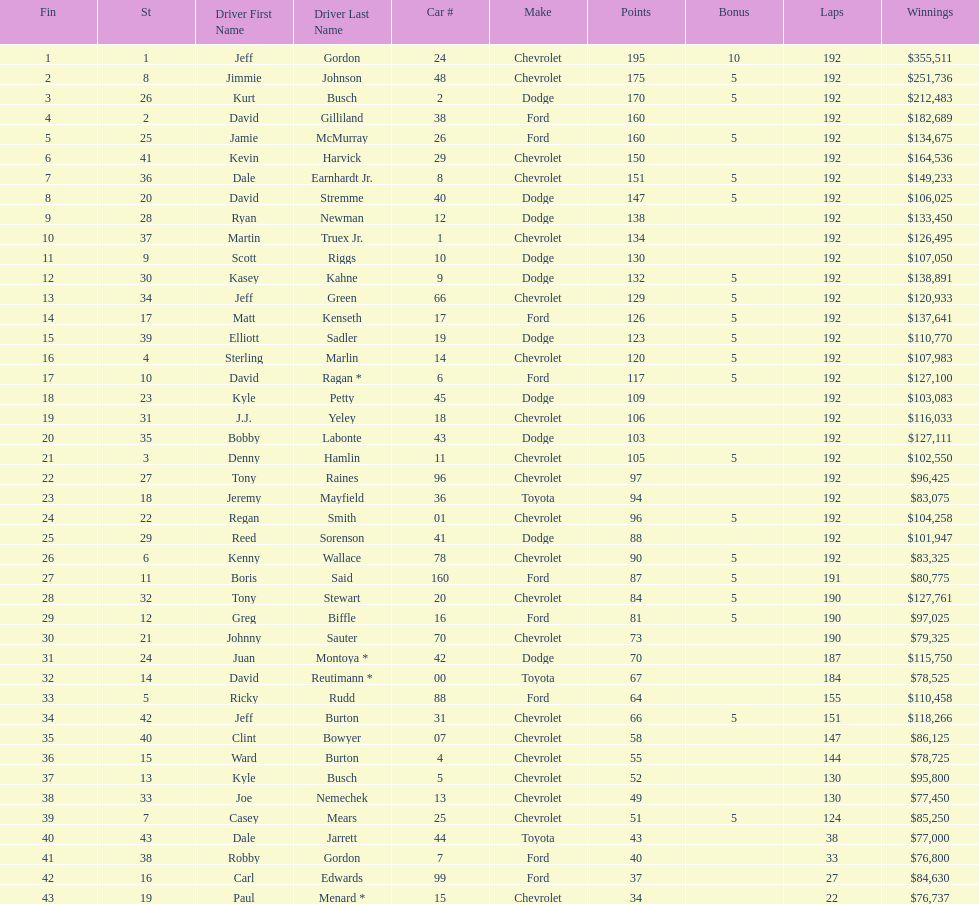Could you parse the entire table? {'header': ['Fin', 'St', 'Driver First Name', 'Driver Last Name', 'Car #', 'Make', 'Points', 'Bonus', 'Laps', 'Winnings'], 'rows': [['1', '1', 'Jeff', 'Gordon', '24', 'Chevrolet', '195', '10', '192', '$355,511'], ['2', '8', 'Jimmie', 'Johnson', '48', 'Chevrolet', '175', '5', '192', '$251,736'], ['3', '26', 'Kurt', 'Busch', '2', 'Dodge', '170', '5', '192', '$212,483'], ['4', '2', 'David', 'Gilliland', '38', 'Ford', '160', '', '192', '$182,689'], ['5', '25', 'Jamie', 'McMurray', '26', 'Ford', '160', '5', '192', '$134,675'], ['6', '41', 'Kevin', 'Harvick', '29', 'Chevrolet', '150', '', '192', '$164,536'], ['7', '36', 'Dale', 'Earnhardt Jr.', '8', 'Chevrolet', '151', '5', '192', '$149,233'], ['8', '20', 'David', 'Stremme', '40', 'Dodge', '147', '5', '192', '$106,025'], ['9', '28', 'Ryan', 'Newman', '12', 'Dodge', '138', '', '192', '$133,450'], ['10', '37', 'Martin', 'Truex Jr.', '1', 'Chevrolet', '134', '', '192', '$126,495'], ['11', '9', 'Scott', 'Riggs', '10', 'Dodge', '130', '', '192', '$107,050'], ['12', '30', 'Kasey', 'Kahne', '9', 'Dodge', '132', '5', '192', '$138,891'], ['13', '34', 'Jeff', 'Green', '66', 'Chevrolet', '129', '5', '192', '$120,933'], ['14', '17', 'Matt', 'Kenseth', '17', 'Ford', '126', '5', '192', '$137,641'], ['15', '39', 'Elliott', 'Sadler', '19', 'Dodge', '123', '5', '192', '$110,770'], ['16', '4', 'Sterling', 'Marlin', '14', 'Chevrolet', '120', '5', '192', '$107,983'], ['17', '10', 'David', 'Ragan *', '6', 'Ford', '117', '5', '192', '$127,100'], ['18', '23', 'Kyle', 'Petty', '45', 'Dodge', '109', '', '192', '$103,083'], ['19', '31', 'J.J.', 'Yeley', '18', 'Chevrolet', '106', '', '192', '$116,033'], ['20', '35', 'Bobby', 'Labonte', '43', 'Dodge', '103', '', '192', '$127,111'], ['21', '3', 'Denny', 'Hamlin', '11', 'Chevrolet', '105', '5', '192', '$102,550'], ['22', '27', 'Tony', 'Raines', '96', 'Chevrolet', '97', '', '192', '$96,425'], ['23', '18', 'Jeremy', 'Mayfield', '36', 'Toyota', '94', '', '192', '$83,075'], ['24', '22', 'Regan', 'Smith', '01', 'Chevrolet', '96', '5', '192', '$104,258'], ['25', '29', 'Reed', 'Sorenson', '41', 'Dodge', '88', '', '192', '$101,947'], ['26', '6', 'Kenny', 'Wallace', '78', 'Chevrolet', '90', '5', '192', '$83,325'], ['27', '11', 'Boris', 'Said', '160', 'Ford', '87', '5', '191', '$80,775'], ['28', '32', 'Tony', 'Stewart', '20', 'Chevrolet', '84', '5', '190', '$127,761'], ['29', '12', 'Greg', 'Biffle', '16', 'Ford', '81', '5', '190', '$97,025'], ['30', '21', 'Johnny', 'Sauter', '70', 'Chevrolet', '73', '', '190', '$79,325'], ['31', '24', 'Juan', 'Montoya *', '42', 'Dodge', '70', '', '187', '$115,750'], ['32', '14', 'David', 'Reutimann *', '00', 'Toyota', '67', '', '184', '$78,525'], ['33', '5', 'Ricky', 'Rudd', '88', 'Ford', '64', '', '155', '$110,458'], ['34', '42', 'Jeff', 'Burton', '31', 'Chevrolet', '66', '5', '151', '$118,266'], ['35', '40', 'Clint', 'Bowyer', '07', 'Chevrolet', '58', '', '147', '$86,125'], ['36', '15', 'Ward', 'Burton', '4', 'Chevrolet', '55', '', '144', '$78,725'], ['37', '13', 'Kyle', 'Busch', '5', 'Chevrolet', '52', '', '130', '$95,800'], ['38', '33', 'Joe', 'Nemechek', '13', 'Chevrolet', '49', '', '130', '$77,450'], ['39', '7', 'Casey', 'Mears', '25', 'Chevrolet', '51', '5', '124', '$85,250'], ['40', '43', 'Dale', 'Jarrett', '44', 'Toyota', '43', '', '38', '$77,000'], ['41', '38', 'Robby', 'Gordon', '7', 'Ford', '40', '', '33', '$76,800'], ['42', '16', 'Carl', 'Edwards', '99', 'Ford', '37', '', '27', '$84,630'], ['43', '19', 'Paul', 'Menard *', '15', 'Chevrolet', '34', '', '22', '$76,737']]} Which make had the most consecutive finishes at the aarons 499? Chevrolet. 